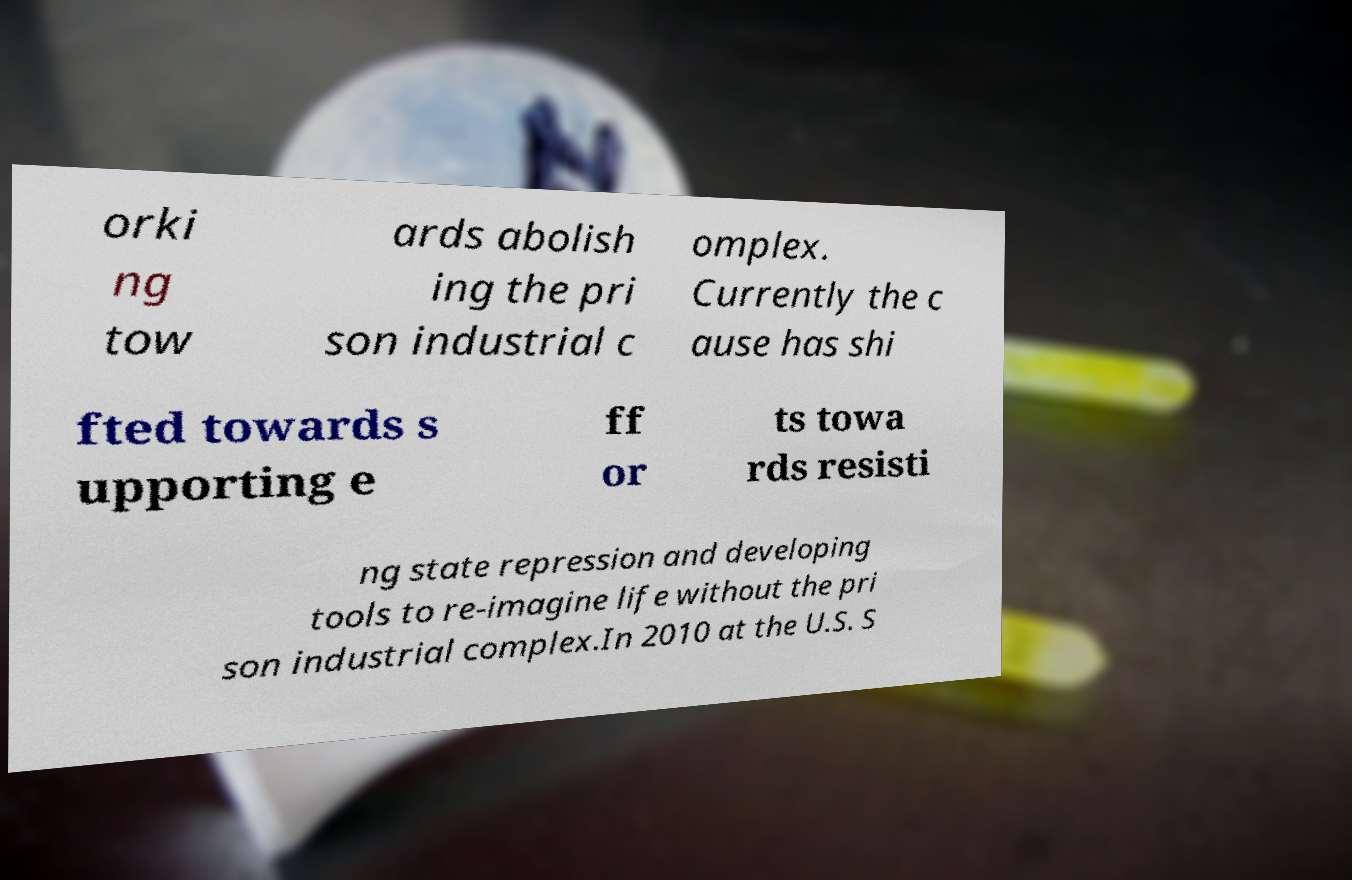I need the written content from this picture converted into text. Can you do that? orki ng tow ards abolish ing the pri son industrial c omplex. Currently the c ause has shi fted towards s upporting e ff or ts towa rds resisti ng state repression and developing tools to re-imagine life without the pri son industrial complex.In 2010 at the U.S. S 